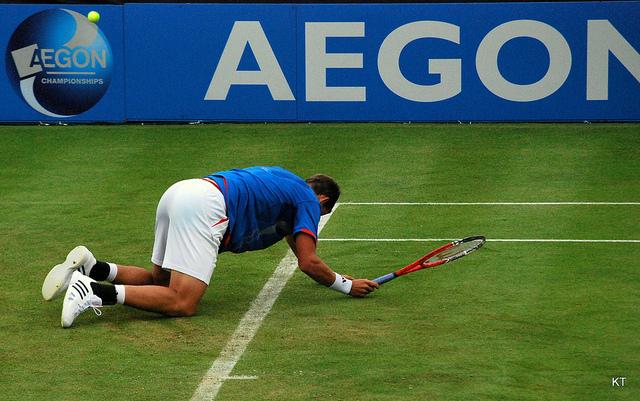What does the sign in the background say?
Answer briefly. Aegon. What sport is this?
Keep it brief. Tennis. Is the player standing?
Give a very brief answer. No. Why is this man so focus on his tennis racket?
Write a very short answer. He lost. 